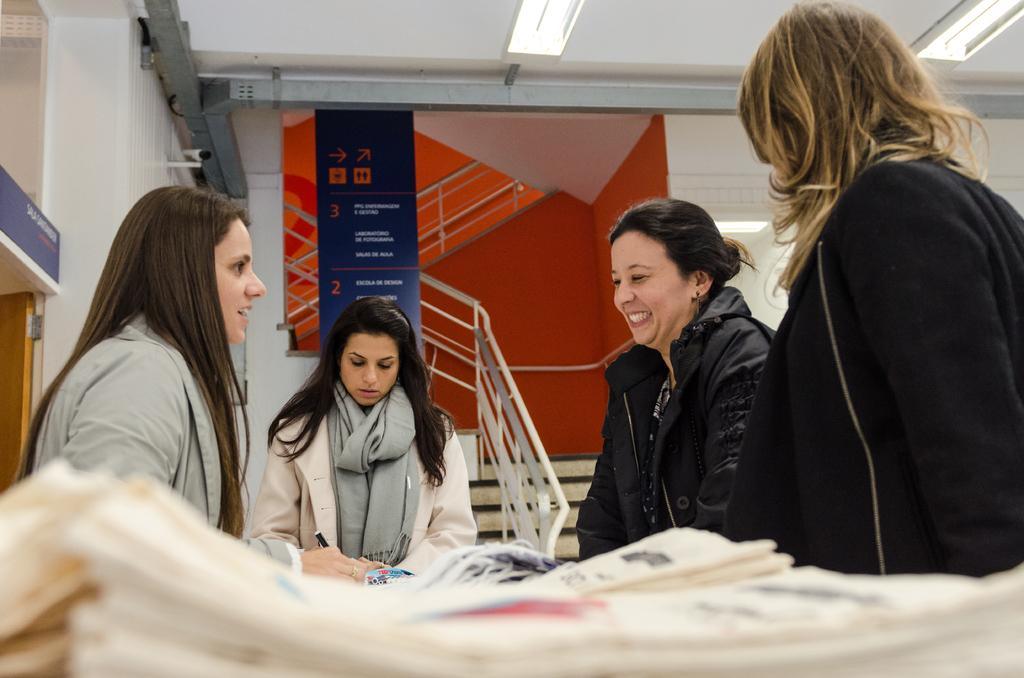Could you give a brief overview of what you see in this image? At the bottom of the image there are papers. Behind the papers there are few ladies. Behind them there is a sign board, railings and also there are steps. On the left side of the image there is a door. And at the top of the image there are lights and also there is a chimney. 